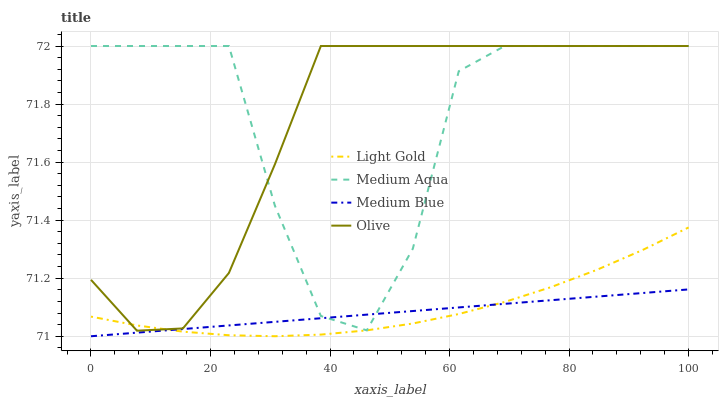Does Light Gold have the minimum area under the curve?
Answer yes or no. No. Does Light Gold have the maximum area under the curve?
Answer yes or no. No. Is Light Gold the smoothest?
Answer yes or no. No. Is Light Gold the roughest?
Answer yes or no. No. Does Light Gold have the lowest value?
Answer yes or no. No. Does Light Gold have the highest value?
Answer yes or no. No. Is Medium Blue less than Olive?
Answer yes or no. Yes. Is Olive greater than Medium Blue?
Answer yes or no. Yes. Does Medium Blue intersect Olive?
Answer yes or no. No. 